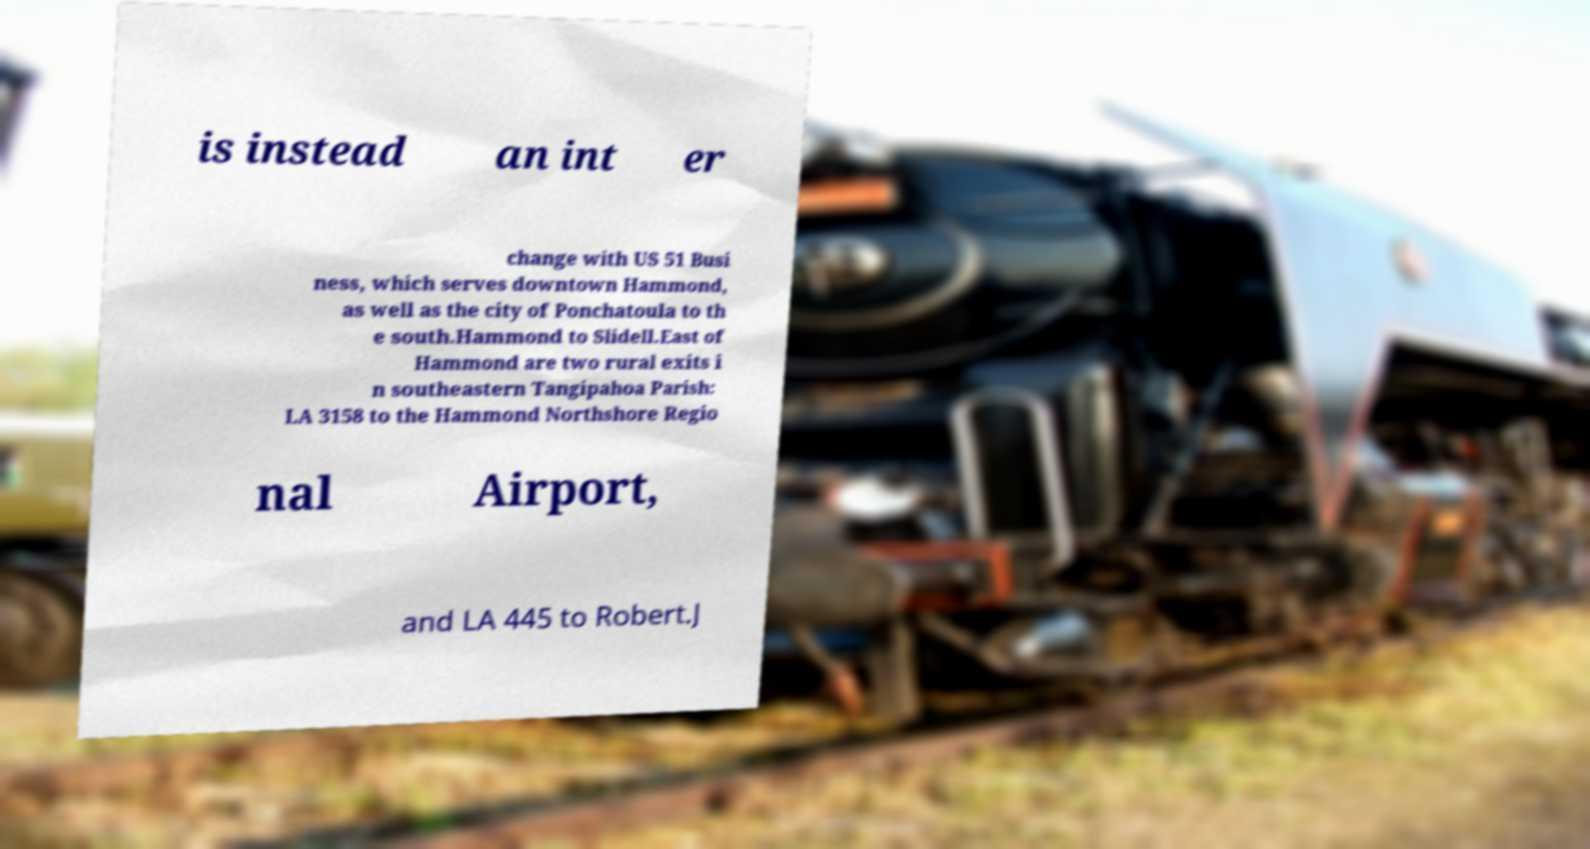Could you assist in decoding the text presented in this image and type it out clearly? is instead an int er change with US 51 Busi ness, which serves downtown Hammond, as well as the city of Ponchatoula to th e south.Hammond to Slidell.East of Hammond are two rural exits i n southeastern Tangipahoa Parish: LA 3158 to the Hammond Northshore Regio nal Airport, and LA 445 to Robert.J 